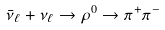<formula> <loc_0><loc_0><loc_500><loc_500>\bar { \nu } _ { \ell } + \nu _ { \ell } \to \rho ^ { 0 } \to \pi ^ { + } \pi ^ { - }</formula> 